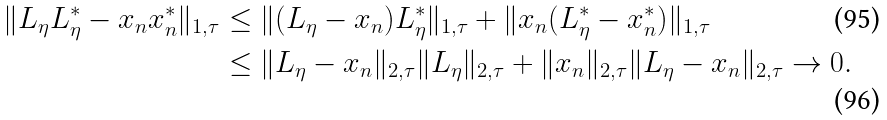<formula> <loc_0><loc_0><loc_500><loc_500>\| L _ { \eta } L _ { \eta } ^ { * } - x _ { n } x _ { n } ^ { * } \| _ { 1 , \tau } & \leq \| ( L _ { \eta } - x _ { n } ) L _ { \eta } ^ { * } \| _ { 1 , \tau } + \| x _ { n } ( L _ { \eta } ^ { * } - x _ { n } ^ { * } ) \| _ { 1 , \tau } \\ & \leq \| L _ { \eta } - x _ { n } \| _ { 2 , \tau } \| L _ { \eta } \| _ { 2 , \tau } + \| x _ { n } \| _ { 2 , \tau } \| L _ { \eta } - x _ { n } \| _ { 2 , \tau } \rightarrow 0 .</formula> 